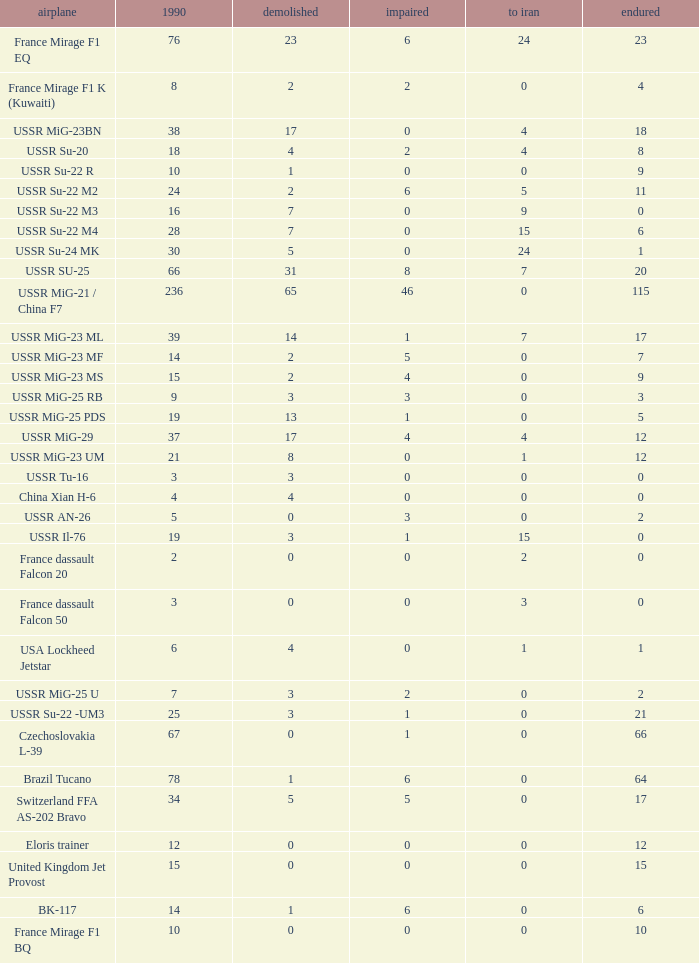If 4 went to iran and the amount that survived was less than 12.0 how many were there in 1990? 1.0. Write the full table. {'header': ['airplane', '1990', 'demolished', 'impaired', 'to iran', 'endured'], 'rows': [['France Mirage F1 EQ', '76', '23', '6', '24', '23'], ['France Mirage F1 K (Kuwaiti)', '8', '2', '2', '0', '4'], ['USSR MiG-23BN', '38', '17', '0', '4', '18'], ['USSR Su-20', '18', '4', '2', '4', '8'], ['USSR Su-22 R', '10', '1', '0', '0', '9'], ['USSR Su-22 M2', '24', '2', '6', '5', '11'], ['USSR Su-22 M3', '16', '7', '0', '9', '0'], ['USSR Su-22 M4', '28', '7', '0', '15', '6'], ['USSR Su-24 MK', '30', '5', '0', '24', '1'], ['USSR SU-25', '66', '31', '8', '7', '20'], ['USSR MiG-21 / China F7', '236', '65', '46', '0', '115'], ['USSR MiG-23 ML', '39', '14', '1', '7', '17'], ['USSR MiG-23 MF', '14', '2', '5', '0', '7'], ['USSR MiG-23 MS', '15', '2', '4', '0', '9'], ['USSR MiG-25 RB', '9', '3', '3', '0', '3'], ['USSR MiG-25 PDS', '19', '13', '1', '0', '5'], ['USSR MiG-29', '37', '17', '4', '4', '12'], ['USSR MiG-23 UM', '21', '8', '0', '1', '12'], ['USSR Tu-16', '3', '3', '0', '0', '0'], ['China Xian H-6', '4', '4', '0', '0', '0'], ['USSR AN-26', '5', '0', '3', '0', '2'], ['USSR Il-76', '19', '3', '1', '15', '0'], ['France dassault Falcon 20', '2', '0', '0', '2', '0'], ['France dassault Falcon 50', '3', '0', '0', '3', '0'], ['USA Lockheed Jetstar', '6', '4', '0', '1', '1'], ['USSR MiG-25 U', '7', '3', '2', '0', '2'], ['USSR Su-22 -UM3', '25', '3', '1', '0', '21'], ['Czechoslovakia L-39', '67', '0', '1', '0', '66'], ['Brazil Tucano', '78', '1', '6', '0', '64'], ['Switzerland FFA AS-202 Bravo', '34', '5', '5', '0', '17'], ['Eloris trainer', '12', '0', '0', '0', '12'], ['United Kingdom Jet Provost', '15', '0', '0', '0', '15'], ['BK-117', '14', '1', '6', '0', '6'], ['France Mirage F1 BQ', '10', '0', '0', '0', '10']]} 